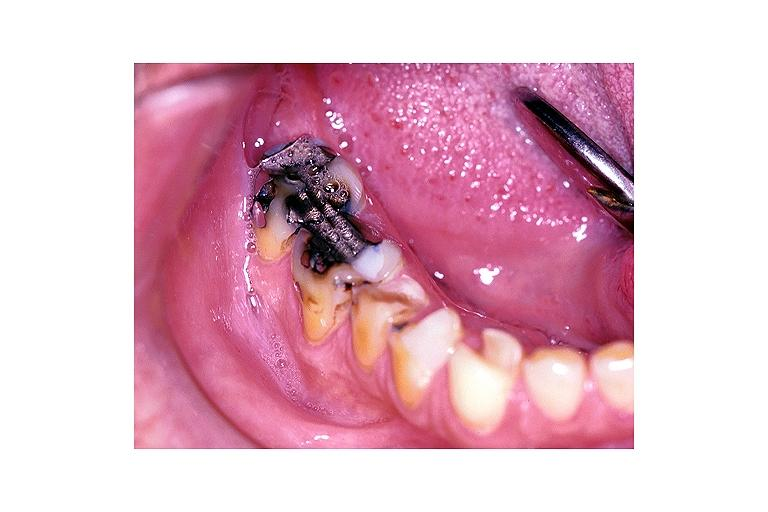s oral present?
Answer the question using a single word or phrase. Yes 